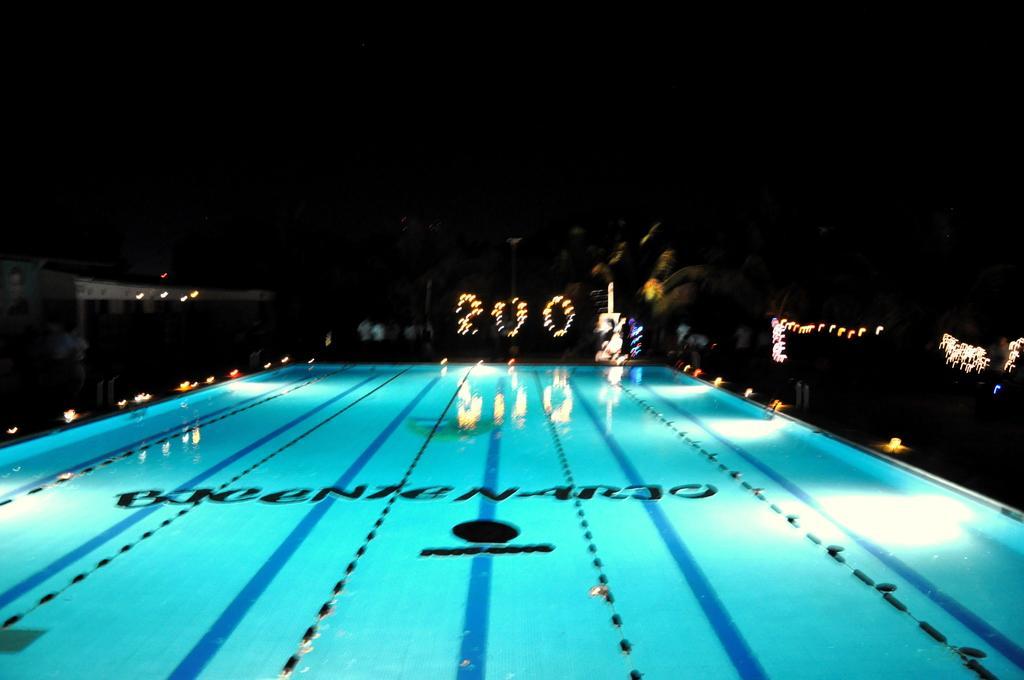Describe this image in one or two sentences. In the center of the image there is a swimming pool. 